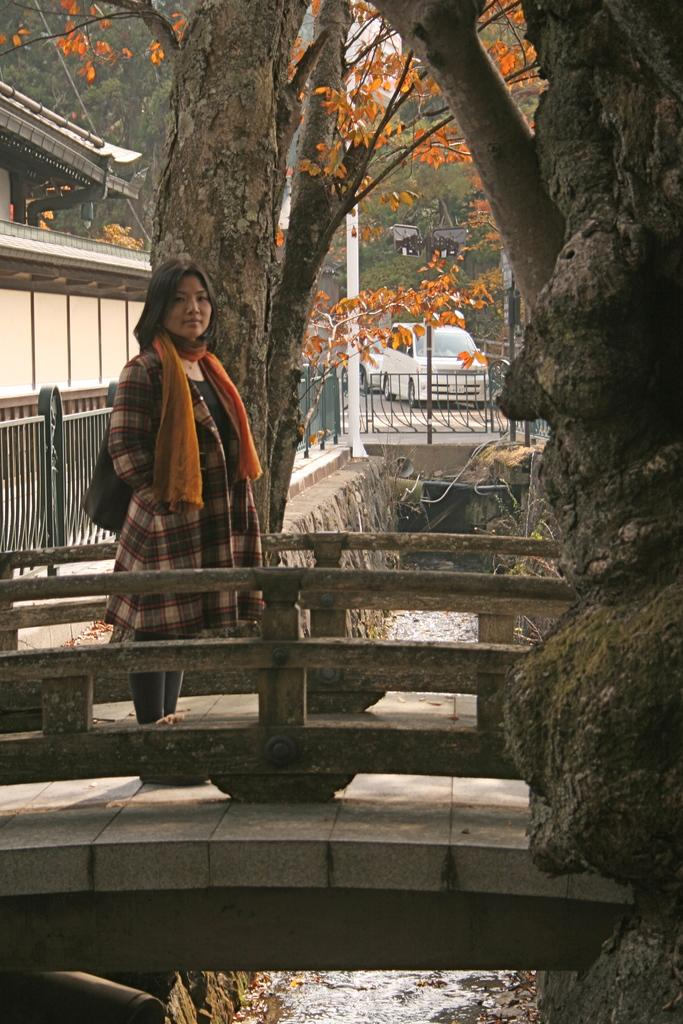What is the woman doing in the image? The woman is standing on a bridge in the image. Where is the bridge located in the image? The bridge is on the left side of the image. What can be seen under the bridge? There is a drainage visible under the bridge. What is visible in the background of the image? There are trees in the background of the image. How many pigs can be seen playing with a rabbit on the bridge in the image? There are no pigs or rabbits present in the image; it features a woman standing on a bridge with a visible drainage and trees in the background. 